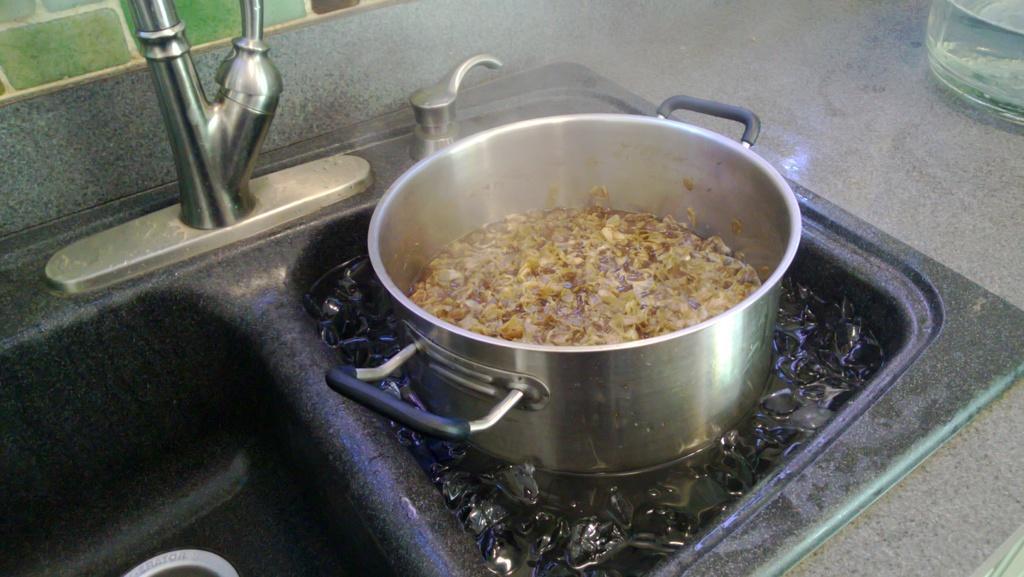Can you describe this image briefly? This image consists of a vessel. It is kept in a sink. In which we can see the ice cubes. In the background, there is a tab and a wall. It looks like it is clicked in the kitchen. 